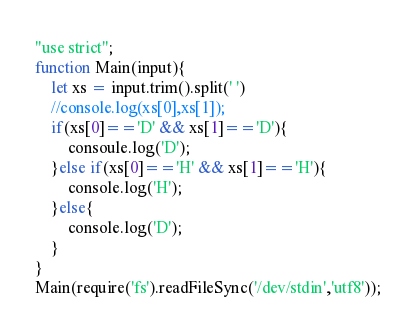Convert code to text. <code><loc_0><loc_0><loc_500><loc_500><_JavaScript_>"use strict";
function Main(input){
	let xs = input.trim().split(' ')
    //console.log(xs[0],xs[1]);
    if(xs[0]=='D' && xs[1]=='D'){
    	consoule.log('D');
    }else if(xs[0]=='H' && xs[1]=='H'){
    	console.log('H');
    }else{
    	console.log('D');
    }
}
Main(require('fs').readFileSync('/dev/stdin','utf8'));</code> 